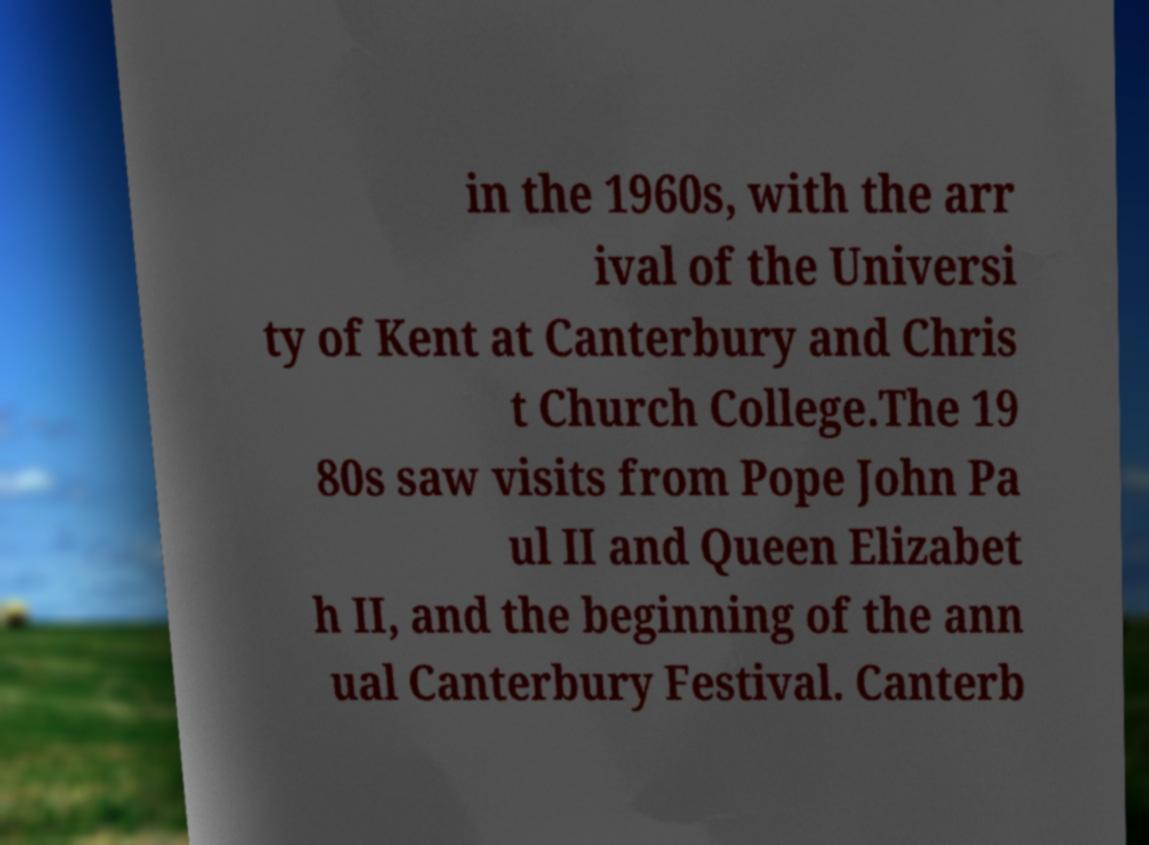For documentation purposes, I need the text within this image transcribed. Could you provide that? in the 1960s, with the arr ival of the Universi ty of Kent at Canterbury and Chris t Church College.The 19 80s saw visits from Pope John Pa ul II and Queen Elizabet h II, and the beginning of the ann ual Canterbury Festival. Canterb 